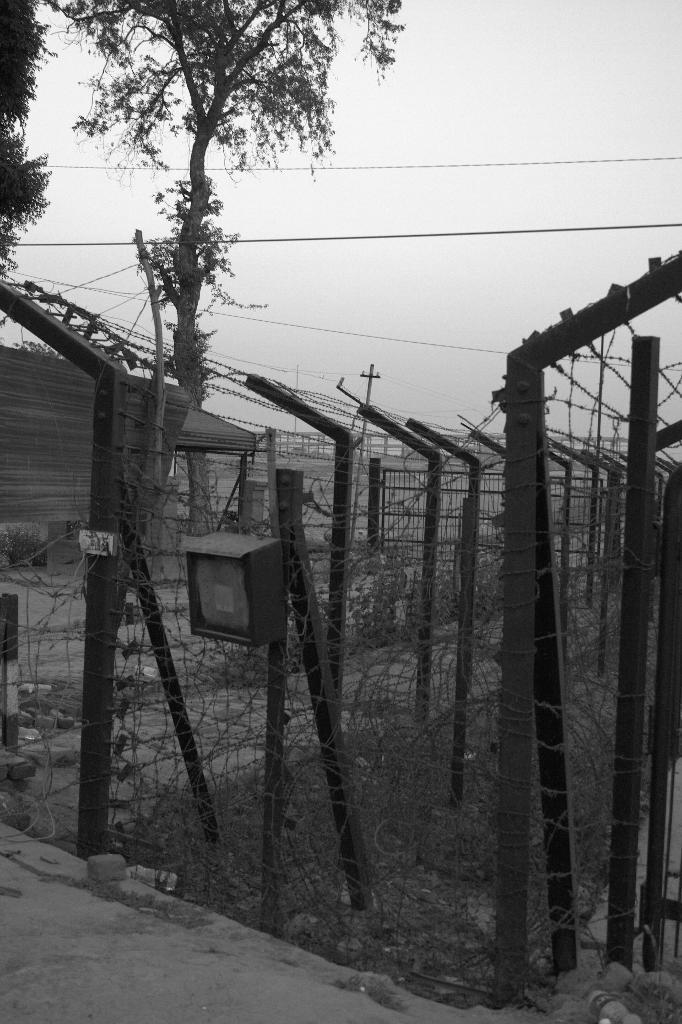What is the color scheme of the image? The image is black and white. What type of natural elements can be seen in the image? There are trees in the image. What type of structure is present in the image? There is a fence with rods in the image. Can you see the mother holding the hose in the image? There is no mother or hose present in the image. Is there a circle drawn on the fence in the image? There is no circle drawn on the fence in the image. 